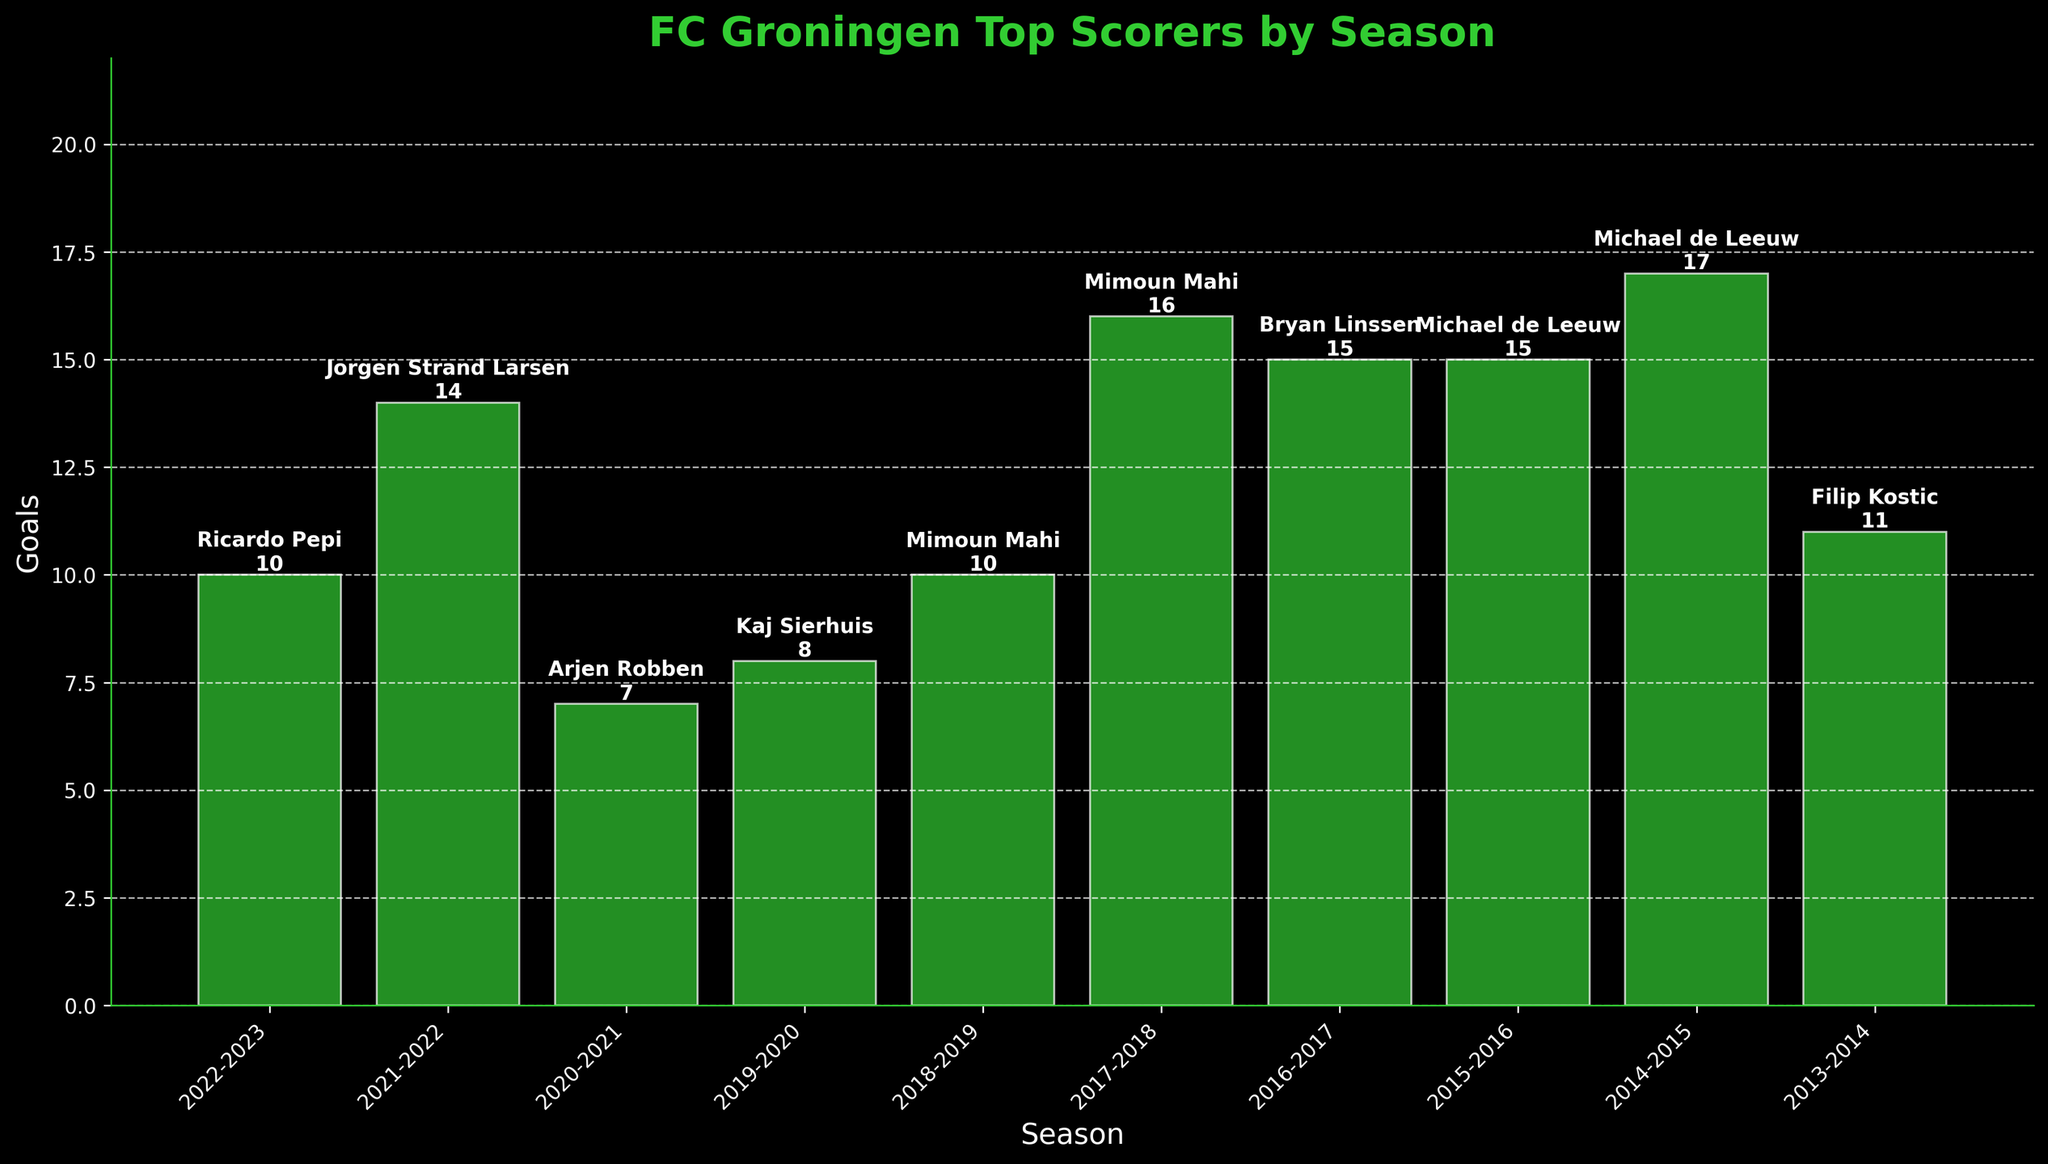Which player scored the most goals in the 2014-2015 season? By looking at the figure for the 2014-2015 bar, you can see that Michael de Leeuw is displayed with the highest goals for that season, with a value of 17 goals.
Answer: Michael de Leeuw Who are the top goal scorers in the 2015-2016 season and their number of goals? The figure for the 2015-2016 season indicates that Michael de Leeuw scored 15 goals, Bryan Linssen scored 12 goals, followed by Danny Hoesen and Albert Rusnák with 7 goals each. Jesper Drost scored 5 goals.
Answer: Michael de Leeuw: 15, Bryan Linssen: 12, Danny Hoesen: 7, Albert Rusnák: 7, Jesper Drost: 5 Which season had the highest top scorer and how many goals were scored? From the figure, Mimoun Mahi in the 2017-2018 season appears to have the highest number of goals, with a total of 16 goals.
Answer: 2017-2018, 16 goals What is the difference in the top scorer’s goals between the 2021-2022 and 2020-2021 seasons? For 2021-2022, Jorgen Strand Larsen is the top scorer with 14 goals. For 2020-2021, both Arjen Robben and Ahmed El Messaoudi tied with 7 goals each as top scorers. The difference is 14 - 7 = 7 goals.
Answer: 7 goals Which player had the highest goals in the 2022-2023 season, and how does it compare to the top scorer in the 2013-2014 season? Ricardo Pepi was the top scorer with 10 goals in 2022-2023, whereas Filip Kostic had 11 goals in the 2013-2014 season. The comparison shows a difference of 11 - 10 = 1 goal, with Kostic scoring more.
Answer: 1 goal less What is the average number of goals scored by the top scorer over the 10 seasons? Sum up the goals of each top scorer from all seasons: 10 + 14 + 7 + 8 + 10 + 16 + 15 + 15 + 17 + 11 = 123 goals. Divide by the 10 seasons: 123 / 10 = 12.3 goals.
Answer: 12.3 goals Which seasons saw Mimoun Mahi as the top scorer and with how many goals each? Mimoun Mahi was the top scorer in the 2017-2018 season with 16 goals and 2016-2017 season with 12 goals.
Answer: 2017-2018: 16 goals, 2016-2017: 12 goals Compare the top goal scorers in 2018-2019 and 2019-2020 in terms of number of goals scored. Who scored more, and by how much? In 2018-2019, Mimoun Mahi scored 10 goals. In 2019-2020, Kaj Sierhuis scored 8 goals. The difference is 10 - 8 = 2 goals, with Mimoun Mahi scoring more.
Answer: Mimoun Mahi by 2 goals Is there a season where the top scorer was below 10 goals? Yes, the seasons 2020-2021 and 2019-2020 had top scorers below 10 goals; Arjen Robben and Ahmed El Messaoudi with 7 goals, and Kaj Sierhuis with 8 goals, respectively.
Answer: Yes, two seasons 